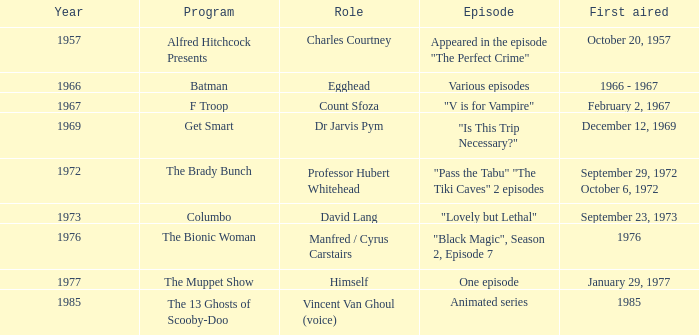What's the first aired date of the Animated Series episode? 1985.0. 